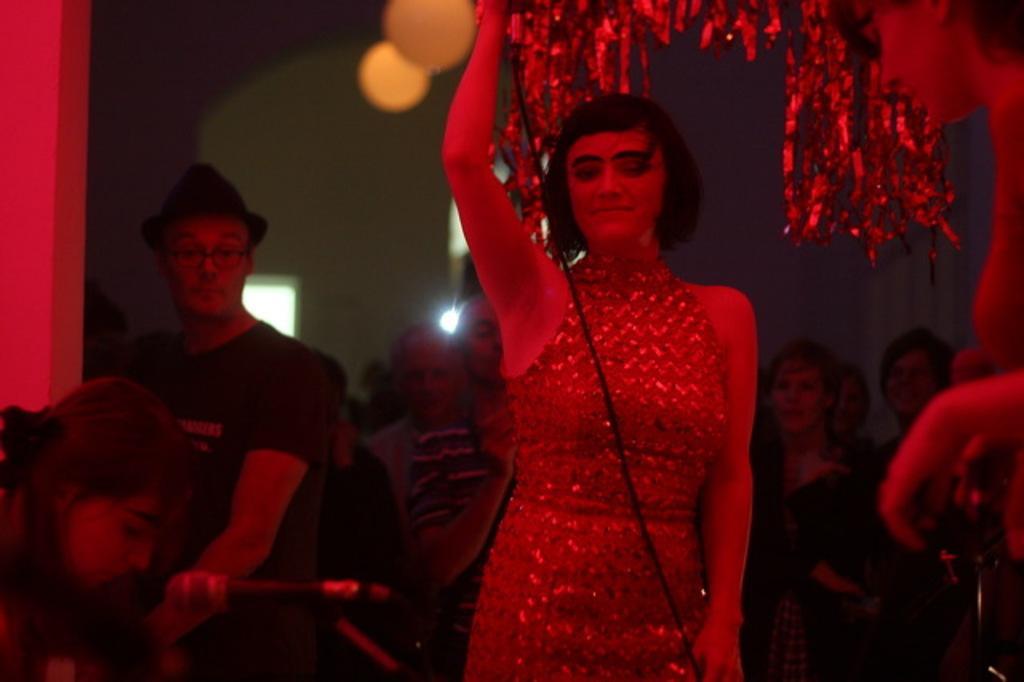Could you give a brief overview of what you see in this image? In this image I can see a woman in the centre of the image holding an object. There are group of people and in the background there are walls. 